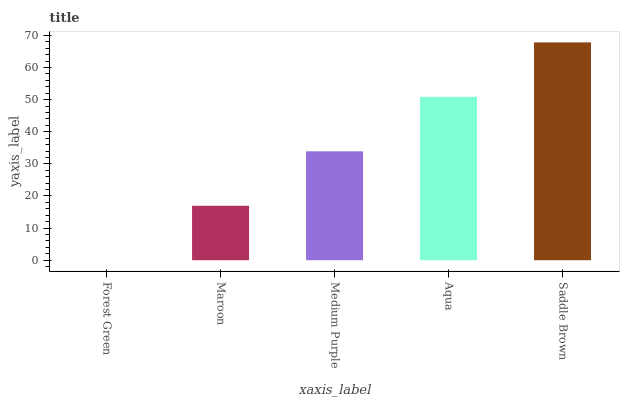Is Forest Green the minimum?
Answer yes or no. Yes. Is Saddle Brown the maximum?
Answer yes or no. Yes. Is Maroon the minimum?
Answer yes or no. No. Is Maroon the maximum?
Answer yes or no. No. Is Maroon greater than Forest Green?
Answer yes or no. Yes. Is Forest Green less than Maroon?
Answer yes or no. Yes. Is Forest Green greater than Maroon?
Answer yes or no. No. Is Maroon less than Forest Green?
Answer yes or no. No. Is Medium Purple the high median?
Answer yes or no. Yes. Is Medium Purple the low median?
Answer yes or no. Yes. Is Maroon the high median?
Answer yes or no. No. Is Forest Green the low median?
Answer yes or no. No. 